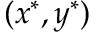<formula> <loc_0><loc_0><loc_500><loc_500>( x ^ { * } , y ^ { * } )</formula> 